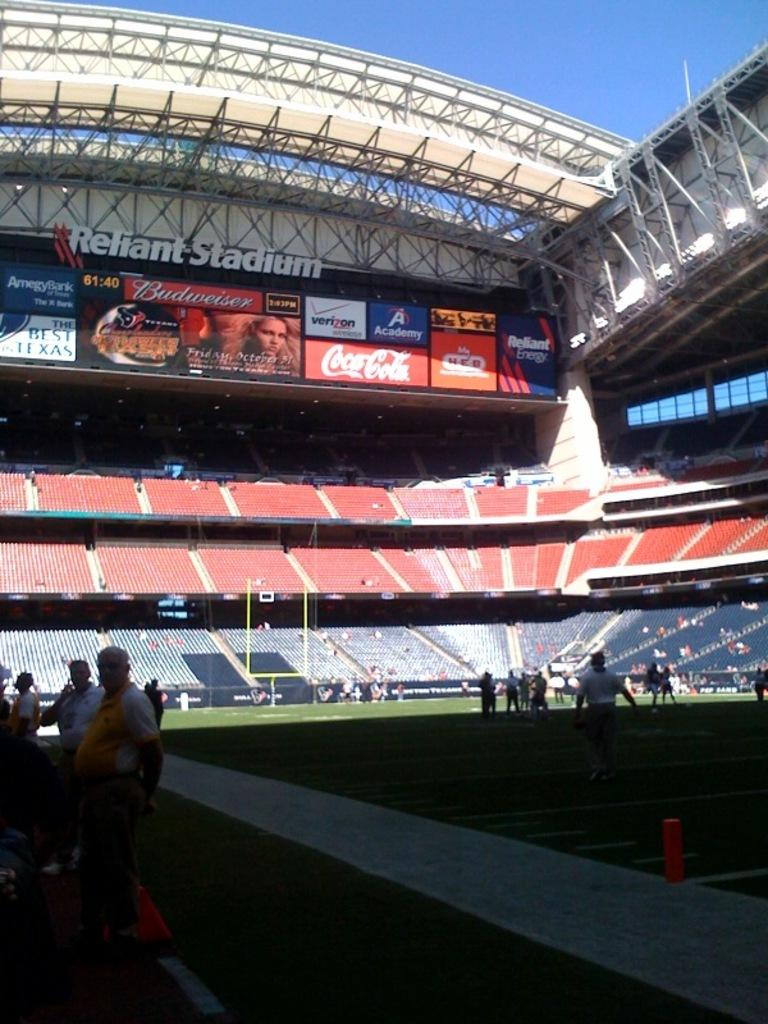Provide a one-sentence caption for the provided image. A view from the inside of a stadium of various advertisements including Coca Cola and Reliant Energy. 